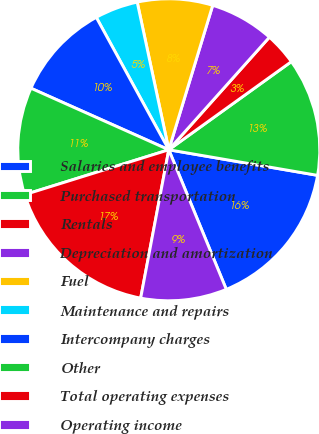<chart> <loc_0><loc_0><loc_500><loc_500><pie_chart><fcel>Salaries and employee benefits<fcel>Purchased transportation<fcel>Rentals<fcel>Depreciation and amortization<fcel>Fuel<fcel>Maintenance and repairs<fcel>Intercompany charges<fcel>Other<fcel>Total operating expenses<fcel>Operating income<nl><fcel>16.07%<fcel>12.63%<fcel>3.47%<fcel>6.91%<fcel>8.05%<fcel>4.62%<fcel>10.34%<fcel>11.49%<fcel>17.21%<fcel>9.2%<nl></chart> 